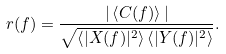<formula> <loc_0><loc_0><loc_500><loc_500>r ( f ) = \frac { | \left < C ( f ) \right > | } { \sqrt { \left < | X ( f ) | ^ { 2 } \right > \left < | Y ( f ) | ^ { 2 } \right > } } .</formula> 